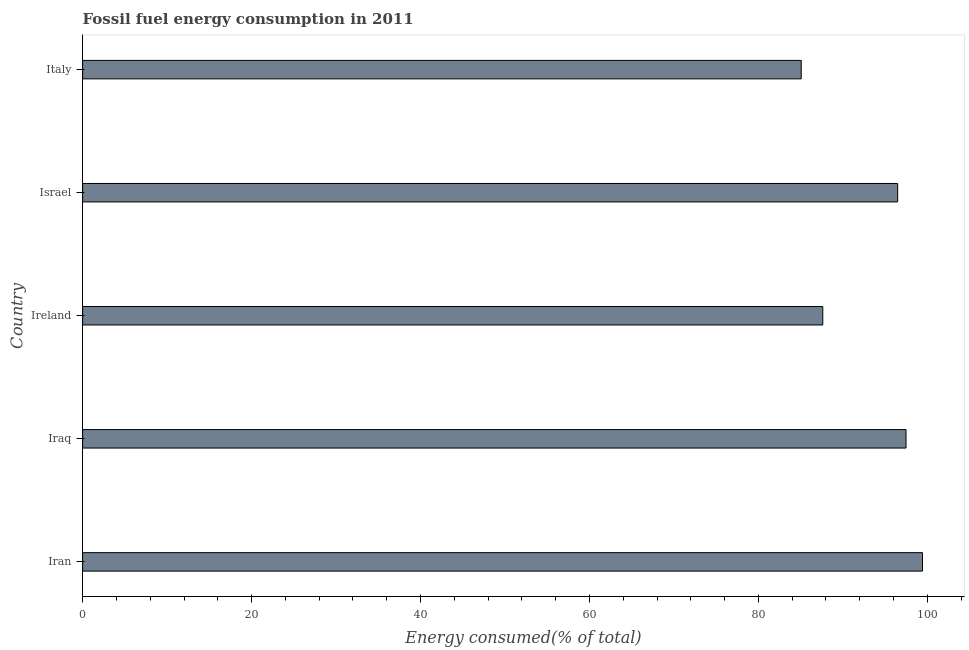Does the graph contain grids?
Provide a succinct answer. No. What is the title of the graph?
Offer a terse response. Fossil fuel energy consumption in 2011. What is the label or title of the X-axis?
Your answer should be compact. Energy consumed(% of total). What is the label or title of the Y-axis?
Provide a succinct answer. Country. What is the fossil fuel energy consumption in Iran?
Provide a short and direct response. 99.43. Across all countries, what is the maximum fossil fuel energy consumption?
Keep it short and to the point. 99.43. Across all countries, what is the minimum fossil fuel energy consumption?
Offer a terse response. 85.07. In which country was the fossil fuel energy consumption maximum?
Keep it short and to the point. Iran. In which country was the fossil fuel energy consumption minimum?
Your answer should be compact. Italy. What is the sum of the fossil fuel energy consumption?
Offer a terse response. 466.09. What is the difference between the fossil fuel energy consumption in Iran and Israel?
Your response must be concise. 2.94. What is the average fossil fuel energy consumption per country?
Your answer should be very brief. 93.22. What is the median fossil fuel energy consumption?
Ensure brevity in your answer.  96.49. In how many countries, is the fossil fuel energy consumption greater than 68 %?
Give a very brief answer. 5. What is the ratio of the fossil fuel energy consumption in Iran to that in Italy?
Make the answer very short. 1.17. What is the difference between the highest and the second highest fossil fuel energy consumption?
Offer a very short reply. 1.95. What is the difference between the highest and the lowest fossil fuel energy consumption?
Give a very brief answer. 14.36. In how many countries, is the fossil fuel energy consumption greater than the average fossil fuel energy consumption taken over all countries?
Provide a succinct answer. 3. Are all the bars in the graph horizontal?
Offer a terse response. Yes. What is the Energy consumed(% of total) of Iran?
Make the answer very short. 99.43. What is the Energy consumed(% of total) in Iraq?
Provide a short and direct response. 97.48. What is the Energy consumed(% of total) of Ireland?
Your answer should be compact. 87.62. What is the Energy consumed(% of total) in Israel?
Provide a short and direct response. 96.49. What is the Energy consumed(% of total) of Italy?
Offer a very short reply. 85.07. What is the difference between the Energy consumed(% of total) in Iran and Iraq?
Offer a terse response. 1.95. What is the difference between the Energy consumed(% of total) in Iran and Ireland?
Ensure brevity in your answer.  11.81. What is the difference between the Energy consumed(% of total) in Iran and Israel?
Your answer should be very brief. 2.94. What is the difference between the Energy consumed(% of total) in Iran and Italy?
Your answer should be compact. 14.36. What is the difference between the Energy consumed(% of total) in Iraq and Ireland?
Keep it short and to the point. 9.86. What is the difference between the Energy consumed(% of total) in Iraq and Israel?
Your response must be concise. 0.99. What is the difference between the Energy consumed(% of total) in Iraq and Italy?
Your response must be concise. 12.41. What is the difference between the Energy consumed(% of total) in Ireland and Israel?
Offer a very short reply. -8.86. What is the difference between the Energy consumed(% of total) in Ireland and Italy?
Give a very brief answer. 2.55. What is the difference between the Energy consumed(% of total) in Israel and Italy?
Your answer should be compact. 11.42. What is the ratio of the Energy consumed(% of total) in Iran to that in Ireland?
Your answer should be very brief. 1.14. What is the ratio of the Energy consumed(% of total) in Iran to that in Italy?
Your answer should be compact. 1.17. What is the ratio of the Energy consumed(% of total) in Iraq to that in Ireland?
Keep it short and to the point. 1.11. What is the ratio of the Energy consumed(% of total) in Iraq to that in Italy?
Keep it short and to the point. 1.15. What is the ratio of the Energy consumed(% of total) in Ireland to that in Israel?
Give a very brief answer. 0.91. What is the ratio of the Energy consumed(% of total) in Ireland to that in Italy?
Your response must be concise. 1.03. What is the ratio of the Energy consumed(% of total) in Israel to that in Italy?
Your answer should be very brief. 1.13. 